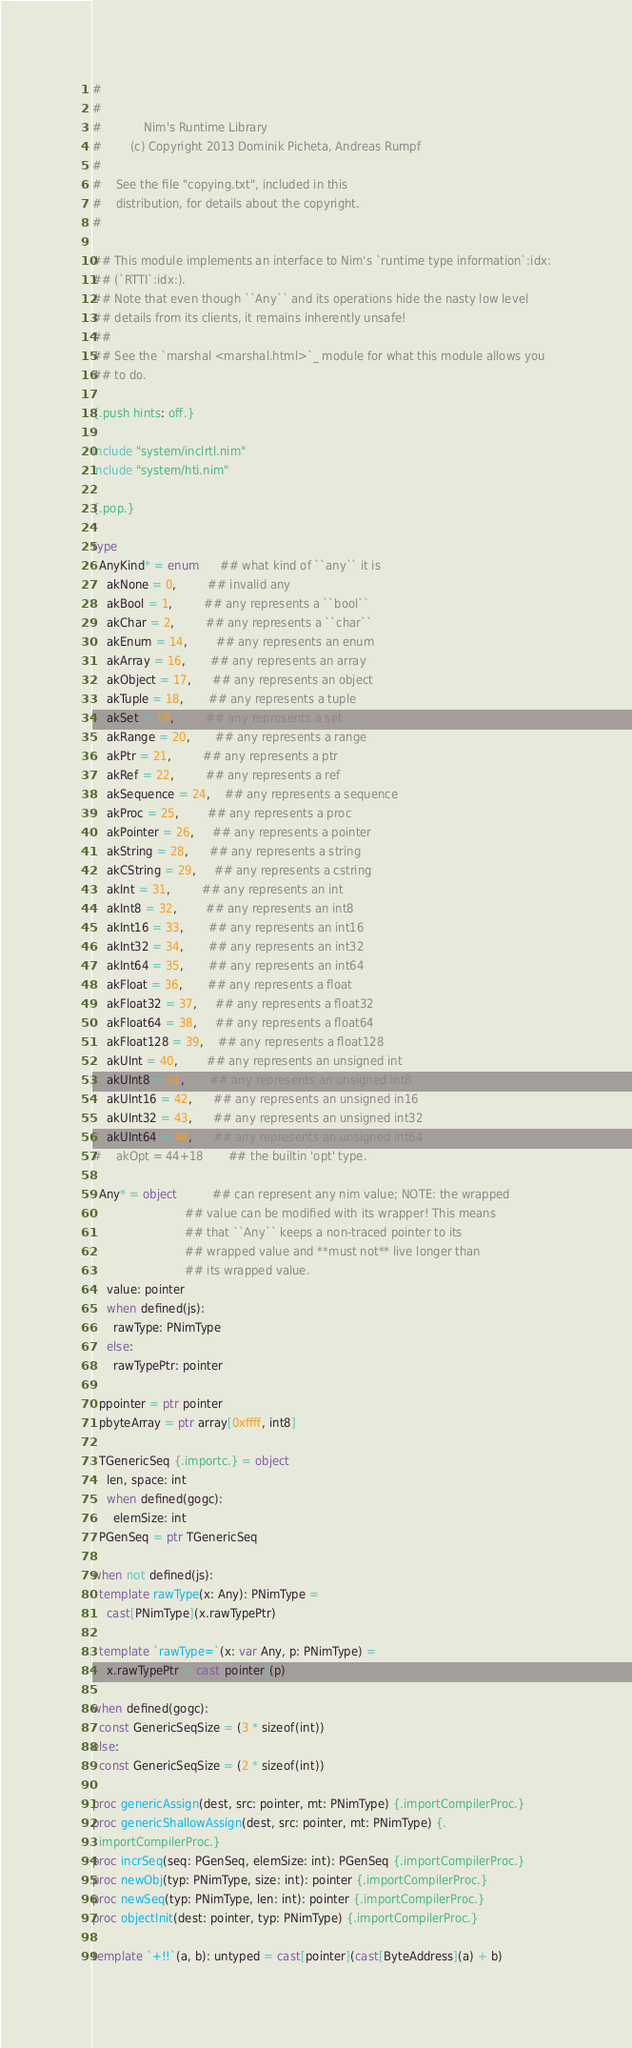<code> <loc_0><loc_0><loc_500><loc_500><_Nim_>#
#
#            Nim's Runtime Library
#        (c) Copyright 2013 Dominik Picheta, Andreas Rumpf
#
#    See the file "copying.txt", included in this
#    distribution, for details about the copyright.
#

## This module implements an interface to Nim's `runtime type information`:idx:
## (`RTTI`:idx:).
## Note that even though ``Any`` and its operations hide the nasty low level
## details from its clients, it remains inherently unsafe!
##
## See the `marshal <marshal.html>`_ module for what this module allows you
## to do.

{.push hints: off.}

include "system/inclrtl.nim"
include "system/hti.nim"

{.pop.}

type
  AnyKind* = enum      ## what kind of ``any`` it is
    akNone = 0,         ## invalid any
    akBool = 1,         ## any represents a ``bool``
    akChar = 2,         ## any represents a ``char``
    akEnum = 14,        ## any represents an enum
    akArray = 16,       ## any represents an array
    akObject = 17,      ## any represents an object
    akTuple = 18,       ## any represents a tuple
    akSet = 19,         ## any represents a set
    akRange = 20,       ## any represents a range
    akPtr = 21,         ## any represents a ptr
    akRef = 22,         ## any represents a ref
    akSequence = 24,    ## any represents a sequence
    akProc = 25,        ## any represents a proc
    akPointer = 26,     ## any represents a pointer
    akString = 28,      ## any represents a string
    akCString = 29,     ## any represents a cstring
    akInt = 31,         ## any represents an int
    akInt8 = 32,        ## any represents an int8
    akInt16 = 33,       ## any represents an int16
    akInt32 = 34,       ## any represents an int32
    akInt64 = 35,       ## any represents an int64
    akFloat = 36,       ## any represents a float
    akFloat32 = 37,     ## any represents a float32
    akFloat64 = 38,     ## any represents a float64
    akFloat128 = 39,    ## any represents a float128
    akUInt = 40,        ## any represents an unsigned int
    akUInt8 = 41,       ## any represents an unsigned int8
    akUInt16 = 42,      ## any represents an unsigned in16
    akUInt32 = 43,      ## any represents an unsigned int32
    akUInt64 = 44,      ## any represents an unsigned int64
#    akOpt = 44+18       ## the builtin 'opt' type.

  Any* = object          ## can represent any nim value; NOTE: the wrapped
                          ## value can be modified with its wrapper! This means
                          ## that ``Any`` keeps a non-traced pointer to its
                          ## wrapped value and **must not** live longer than
                          ## its wrapped value.
    value: pointer
    when defined(js):
      rawType: PNimType
    else:
      rawTypePtr: pointer

  ppointer = ptr pointer
  pbyteArray = ptr array[0xffff, int8]

  TGenericSeq {.importc.} = object
    len, space: int
    when defined(gogc):
      elemSize: int
  PGenSeq = ptr TGenericSeq

when not defined(js):
  template rawType(x: Any): PNimType =
    cast[PNimType](x.rawTypePtr)

  template `rawType=`(x: var Any, p: PNimType) =
    x.rawTypePtr = cast[pointer](p)

when defined(gogc):
  const GenericSeqSize = (3 * sizeof(int))
else:
  const GenericSeqSize = (2 * sizeof(int))

proc genericAssign(dest, src: pointer, mt: PNimType) {.importCompilerProc.}
proc genericShallowAssign(dest, src: pointer, mt: PNimType) {.
  importCompilerProc.}
proc incrSeq(seq: PGenSeq, elemSize: int): PGenSeq {.importCompilerProc.}
proc newObj(typ: PNimType, size: int): pointer {.importCompilerProc.}
proc newSeq(typ: PNimType, len: int): pointer {.importCompilerProc.}
proc objectInit(dest: pointer, typ: PNimType) {.importCompilerProc.}

template `+!!`(a, b): untyped = cast[pointer](cast[ByteAddress](a) + b)
</code> 